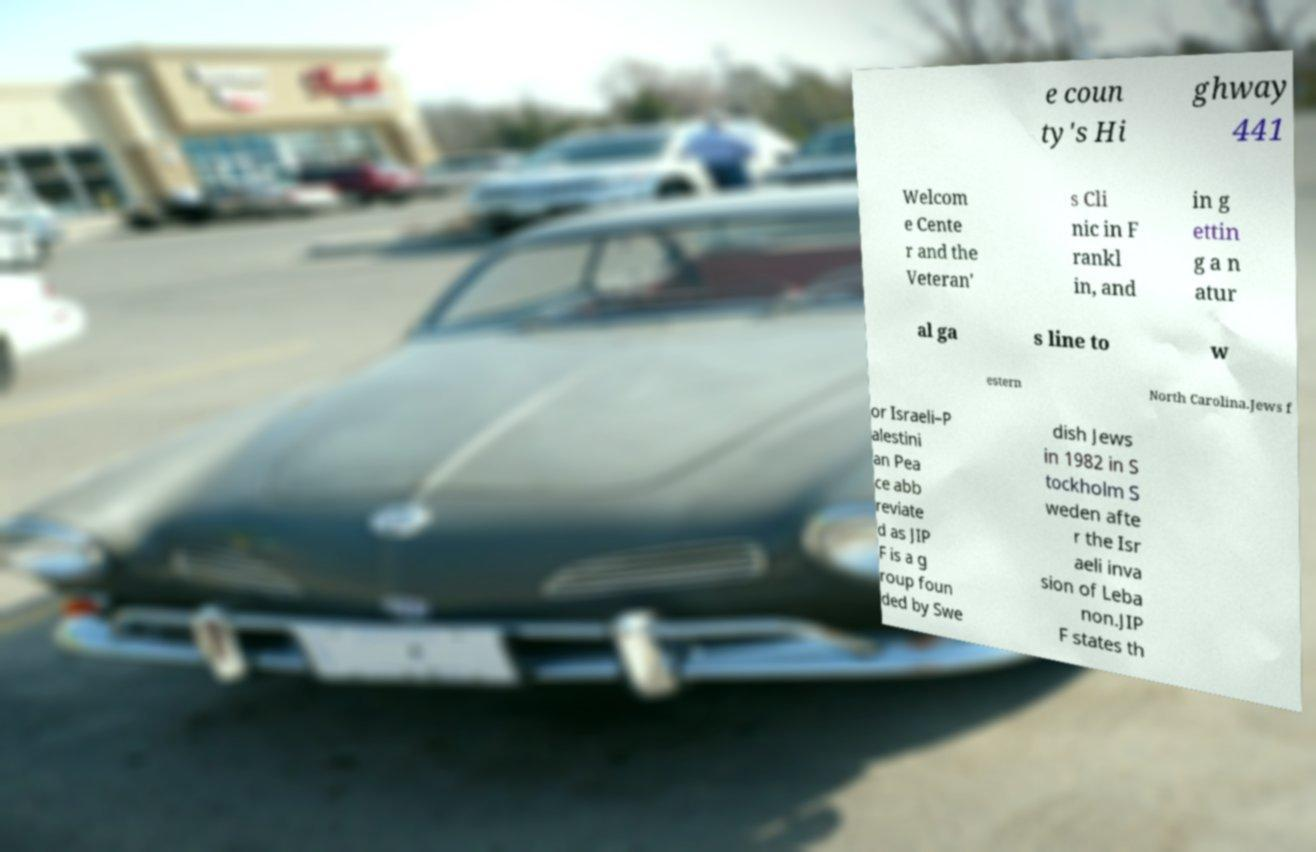Please identify and transcribe the text found in this image. e coun ty's Hi ghway 441 Welcom e Cente r and the Veteran' s Cli nic in F rankl in, and in g ettin g a n atur al ga s line to w estern North Carolina.Jews f or Israeli–P alestini an Pea ce abb reviate d as JIP F is a g roup foun ded by Swe dish Jews in 1982 in S tockholm S weden afte r the Isr aeli inva sion of Leba non.JIP F states th 